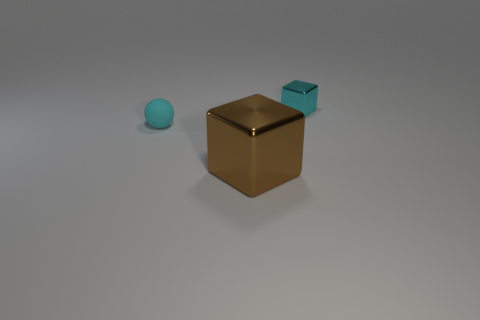There is a small ball that is the same color as the tiny metallic cube; what is its material?
Ensure brevity in your answer.  Rubber. What material is the thing that is the same size as the cyan block?
Keep it short and to the point. Rubber. Is there a green block of the same size as the cyan matte sphere?
Provide a short and direct response. No. Is the matte object the same shape as the large thing?
Ensure brevity in your answer.  No. There is a metallic cube that is in front of the matte object that is behind the large brown metallic block; is there a big brown metallic cube in front of it?
Offer a terse response. No. How many other objects are the same color as the sphere?
Your response must be concise. 1. There is a cyan thing that is to the left of the brown shiny object; is its size the same as the cyan object behind the cyan matte ball?
Keep it short and to the point. Yes. Are there the same number of cyan balls left of the rubber thing and cyan metallic cubes left of the cyan shiny cube?
Your answer should be compact. Yes. Are there any other things that are made of the same material as the large block?
Your answer should be very brief. Yes. There is a cyan sphere; is its size the same as the block that is in front of the cyan shiny cube?
Provide a short and direct response. No. 